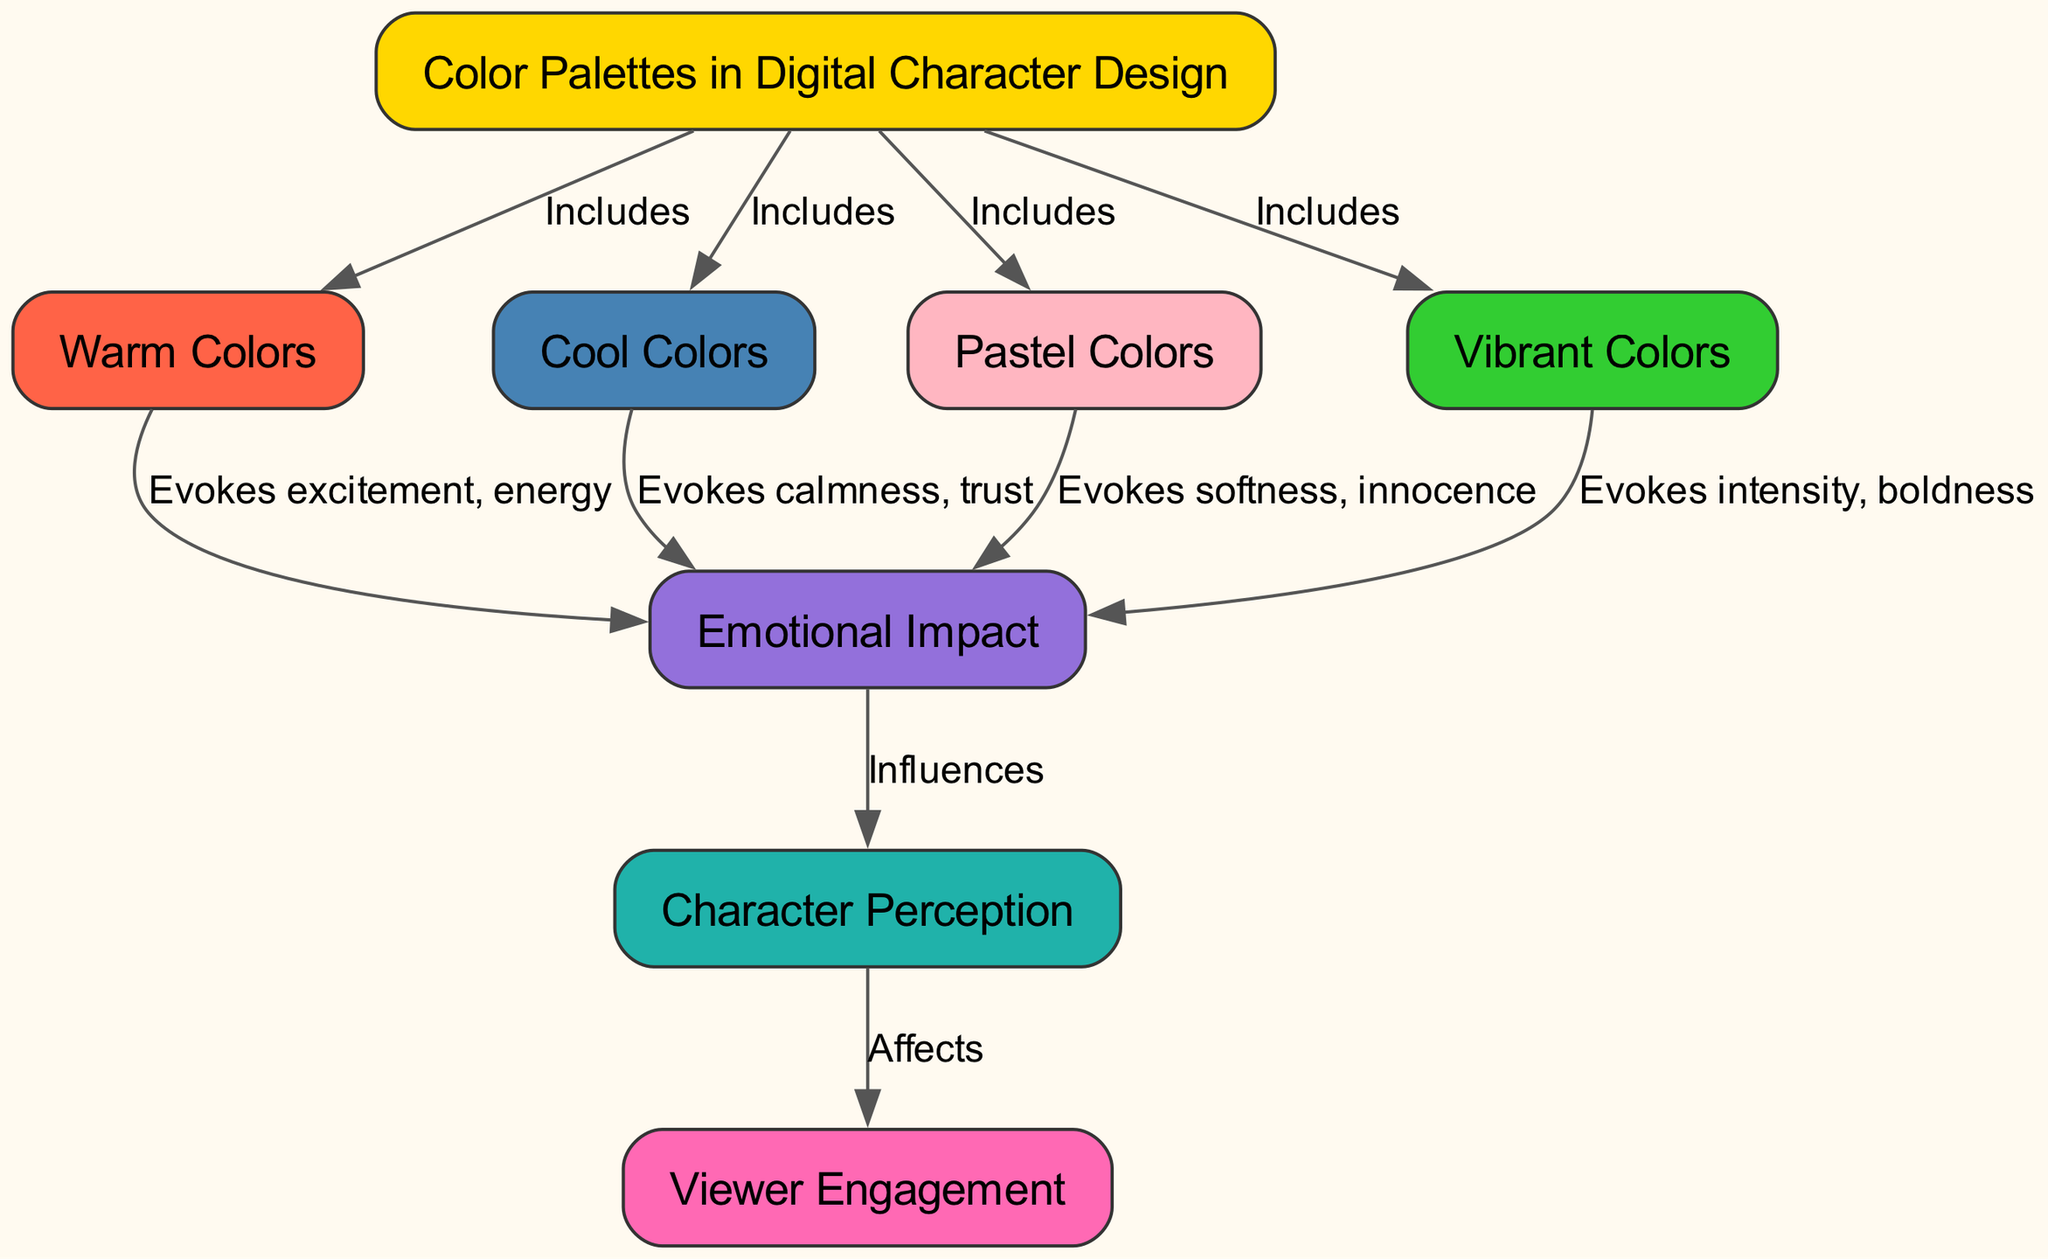What are the four types of color palettes mentioned? The diagram lists four types of color palettes: Warm Colors, Cool Colors, Pastel Colors, and Vibrant Colors. Each is represented as a node connected to the main node "Color Palettes in Digital Character Design".
Answer: Warm Colors, Cool Colors, Pastel Colors, Vibrant Colors How many edges are present in the diagram? To find the number of edges, we count each directed line connecting the nodes. The diagram features a total of 9 edges.
Answer: 9 What emotional impact do warm colors evoke? The diagram states that warm colors evoke excitement and energy, which is indicated by a direct connection from the "Warm Colors" node to the "Emotional Impact" node with this label.
Answer: Excitement, energy Which color palette is associated with calmness and trust? The connection from the "Cool Colors" node illustrates that it evokes calmness and trust, directly linking this palette to the emotional impact described.
Answer: Calmness, trust What influences character perception? The "Emotional Impact" node directly influences "Character Perception", as shown by the edge connecting these two nodes, indicating that the emotional response affects how characters are perceived by viewers.
Answer: Emotional Impact What effect do vibrant colors have according to the diagram? The diagram indicates that vibrant colors evoke intensity and boldness, with a direct link showing this relationship from the "Vibrant Colors" node to the "Emotional Impact" node.
Answer: Intensity, boldness How does viewer engagement relate to character perception? The diagram shows an edge connecting "Character Perception" to "Viewer Engagement", indicating that how viewers perceive characters can directly affect their level of engagement with the content.
Answer: Affects Which color palette evokes softness and innocence? The connection from the "Pastel Colors" node reveals that this palette is associated with feelings of softness and innocence, as captured by the labeling on the edge leading to the "Emotional Impact" node.
Answer: Softness, innocence What is the overall relationship between color palettes and viewer engagement as illustrated in the diagram? The diagram's layout demonstrates a flow from color palettes to emotional impact, then to character perception, and finally to viewer engagement. This illustrates that color palettes influence viewer engagement through emotional responses and character perceptions.
Answer: Influences viewer engagement 